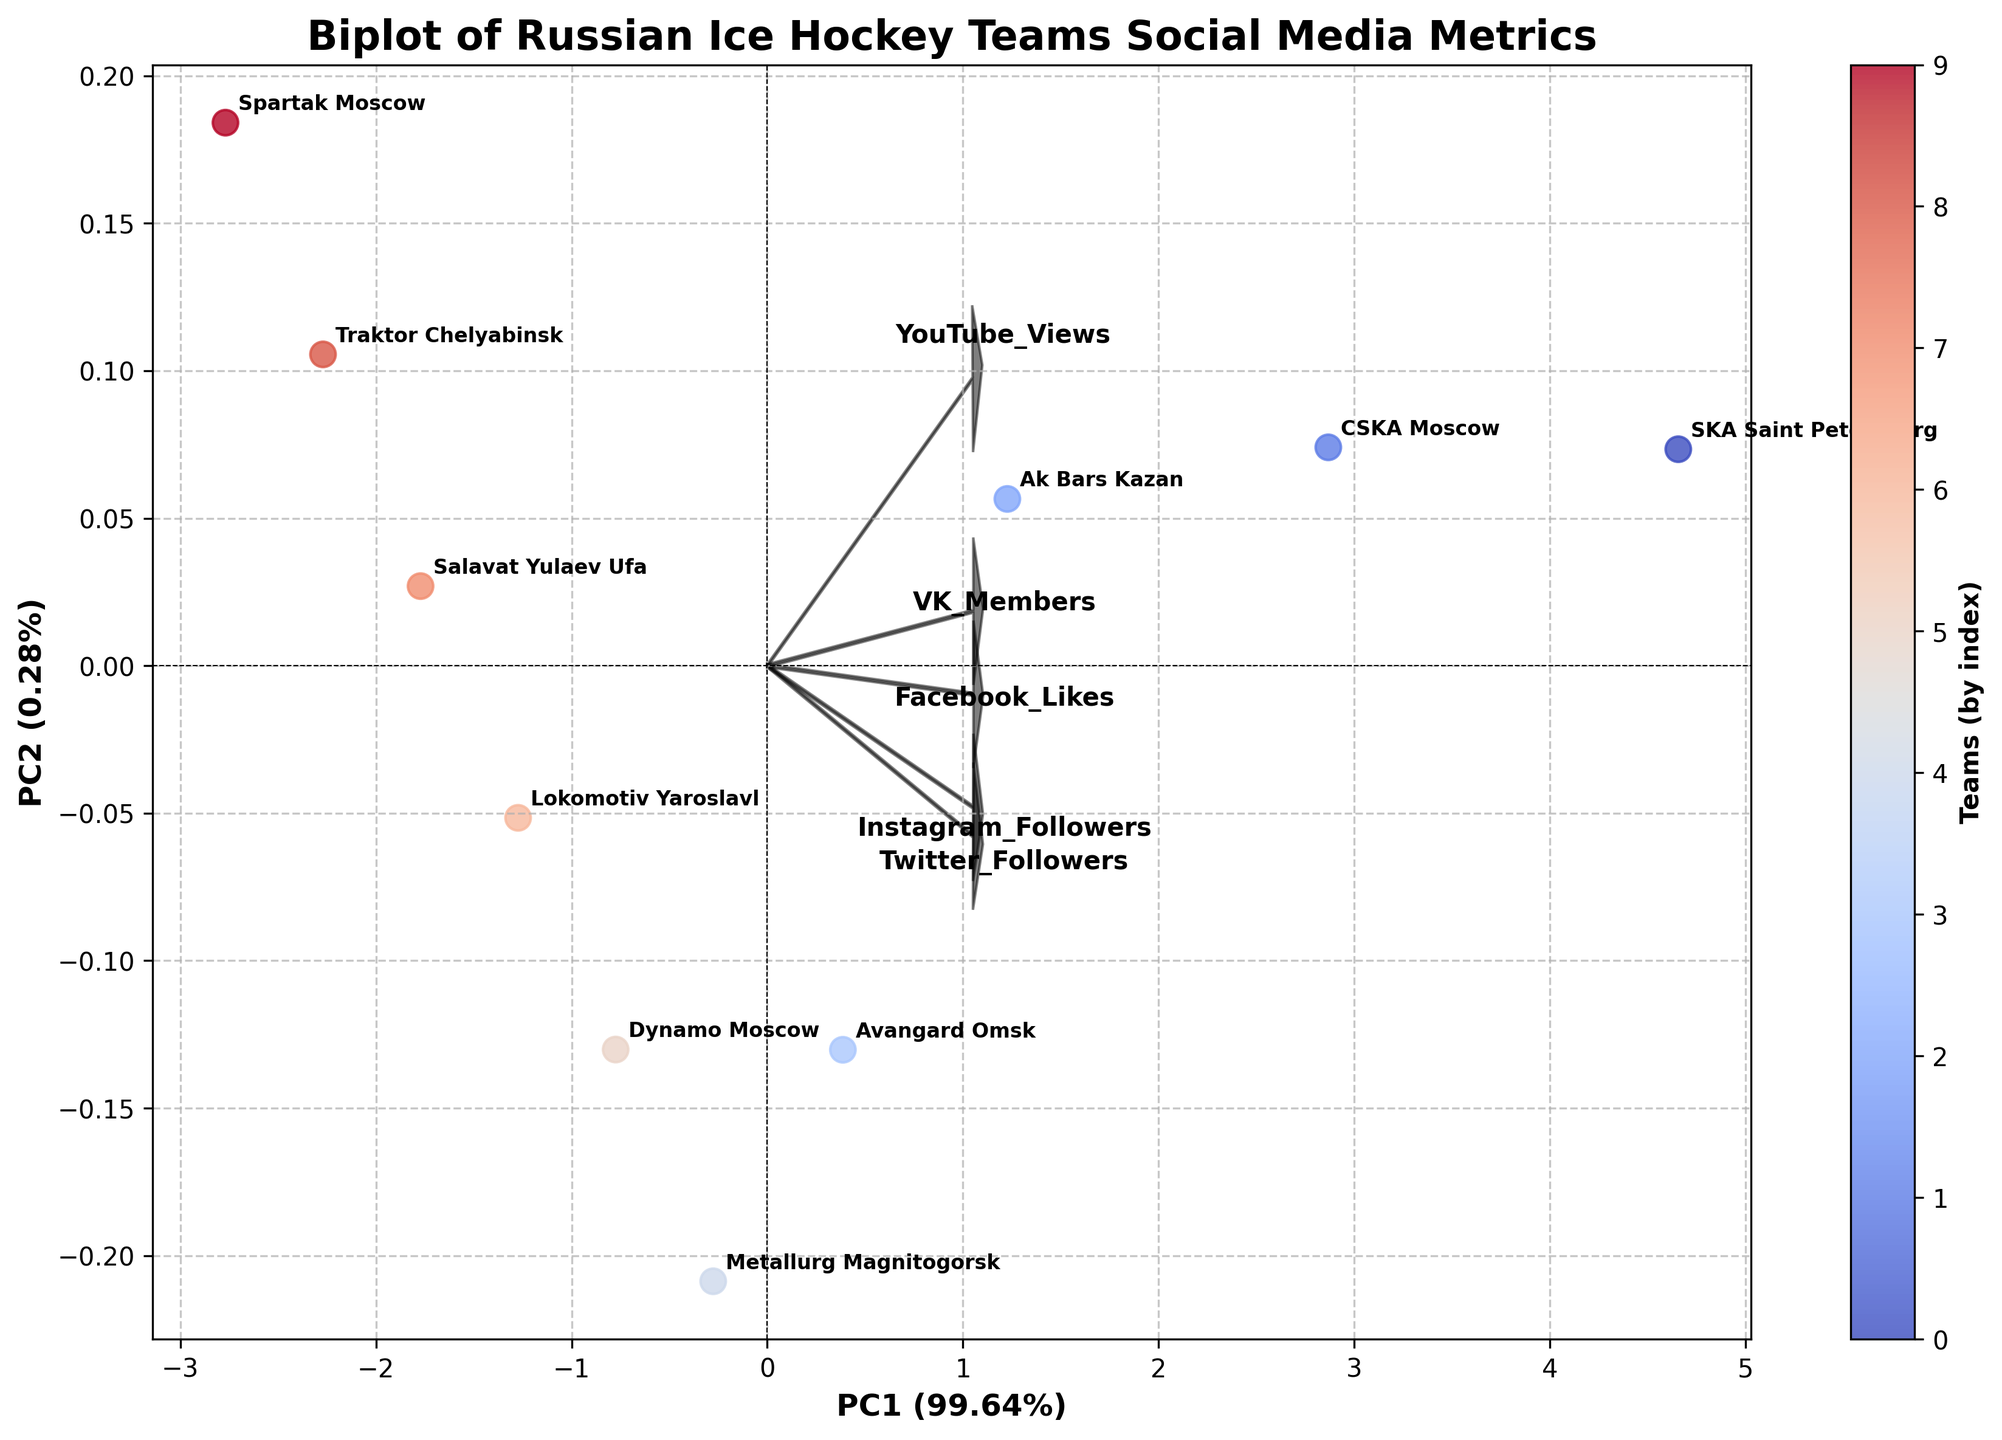What's the title of the figure? The title of the figure is usually situated at the top of the chart. It summarizes the chart's content in a few words. For this figure, the title is "Biplot of Russian Ice Hockey Teams Social Media Metrics"
Answer: Biplot of Russian Ice Hockey Teams Social Media Metrics How many social media metrics are represented in the figure? The figure has loading vectors representing different social media platforms. By counting the loading vectors labeled on the plot, you can determine the number of social media metrics. There are five loading vectors, one for each platform: Instagram Followers, Twitter Followers, YouTube Views, VK Members, and Facebook Likes
Answer: 5 Which team has the highest score on PC1? The scatter points represent the teams, and PC1 is on the x-axis. The team with the highest score on PC1 is the one furthest to the right. The label near the farthest right point is "SKA Saint Petersburg"
Answer: SKA Saint Petersburg Which social media metric contributes most to PC2? The vectors represent the contribution of each metric to the principal components. By examining which vector points most directly to the positive side of the PC2 axis (y-axis), we can determine the metric. The "Facebook Likes" vector points most directly upwards on the PC2 axis
Answer: Facebook Likes How do SKA Saint Petersburg and CSKA Moscow compare in terms of their PC1 and PC2 scores? First, find where each team is plotted on the scatter plot. Then, compare their positions relative to the PC1 (x-axis) and PC2 (y-axis). SKA Saint Petersburg is significantly to the right of CSKA Moscow on PC1 and also slightly higher on PC2
Answer: SKA Saint Petersburg scores higher on both PC1 and PC2 Are Instagram Followers and YouTube Views positively or negatively correlated? To find the correlation between two metrics on a biplot, look at the angles between their vectors. If they are pointing in roughly the same direction, they are positively correlated. The vectors for "Instagram Followers" and "YouTube Views" are close together, indicating a positive correlation
Answer: Positively correlated What percentage of the total variance is explained by PC1 and PC2 combined? The percentage of variance explained by each principal component is usually shown along the axes. For the x-axis (PC1) and y-axis (PC2), sum the percentages. If PC1 explains, for example, 55% and PC2 explains 30%, then combined they account for 85% of the variance
Answer: The sum of percentages on PC1 and PC2 Which team is closest to the origin in the plot? The origin is where the x-axis and y-axis intersect at (0,0). By locating the team label nearest to this point in the plot, we can determine the closest team. "Spartak Moscow" appears closest to the origin
Answer: Spartak Moscow Do VK Members and Facebook Likes have a similar impact on the different teams' engagement? To determine this, compare the lengths and directions of the "VK Members" and "Facebook Likes" vectors. Similar lengths and directions indicate similar impacts. Both vectors are relatively short and point in somewhat similar directions, suggesting a comparable impact across teams
Answer: Similar impact 